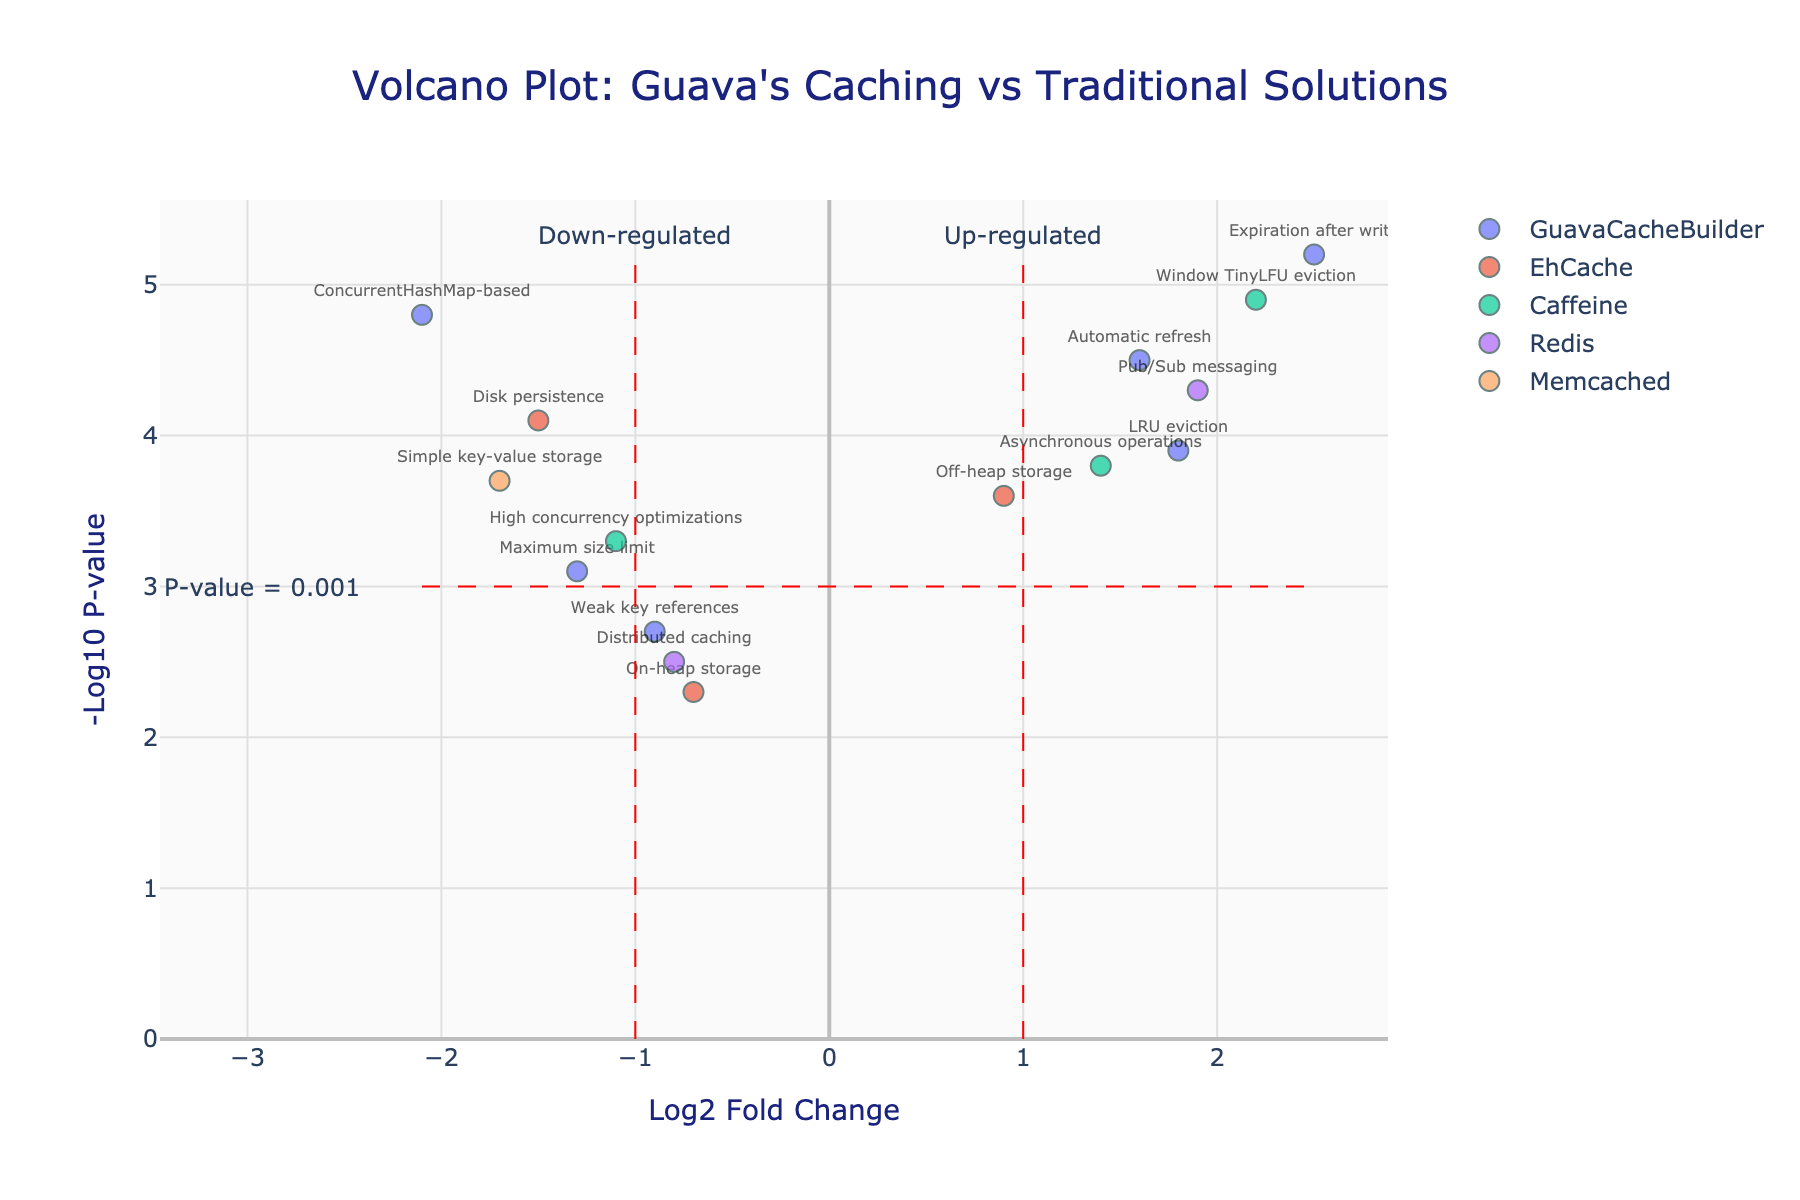What is the title of the figure? The title is displayed at the top of the figure and reads "Volcano Plot: Guava's Caching vs Traditional Solutions."
Answer: Volcano Plot: Guava's Caching vs Traditional Solutions How many data points are representing EhCache features? By examining the legend and the plot, there are three distinct markers labeled as EhCache on the figure.
Answer: 3 Which feature of Redis has the highest -Log10 P-value? By identifying points associated with Redis and checking their positions on the y-axis, the feature with the highest -Log10 P-value is "Pub/Sub messaging" at approximately 4.3.
Answer: Pub/Sub messaging What is the log2 fold change for the Guava feature with "Expiration after write"? Locate the data point labeled "Expiration after write" within the GuavaCacheBuilder marker set. The x-axis position corresponds to a log2 fold change of about 2.5.
Answer: 2.5 Which caching solution has a feature with the lowest log2 fold change? By comparing the x-axis positions, EhCache's "Disk persistence" shows the lowest log2 fold change at approximately -1.5.
Answer: EhCache What is the range of -Log10 P-values for features associated with GuavaCacheBuilder? Find all GuavaCacheBuilder points on the plot and note their y-axis positions. The values range from approximately 2.3 to 5.2.
Answer: 2.3 to 5.2 Which features have a negative log2 fold change but a -Log10 P-value greater than the threshold line (y=3)? Identify points left of x=0 and above y=3. The relevant features are "ConcurrentHashMap-based" and "Maximum size limit."
Answer: ConcurrentHashMap-based, Maximum size limit Compare the "Automatic refresh" feature of GuavaCacheBuilder with "High concurrency optimizations" of Caffeine in terms of both log2 fold change and -Log10 P-value. "Automatic refresh" (GuavaCacheBuilder) has a log2 fold change of 1.6 and -Log10 P-value of 4.5. "High concurrency optimizations" (Caffeine) has a log2 fold change of -1.1 and -Log10 P-value of 3.3. Thus, "Automatic refresh" has a higher log2 fold change and -Log10 P-value.
Answer: Automatic refresh is higher in both From which caching solution is the feature with the highest -Log10 P-value among all data points? By searching the entire plot, the feature with the highest -Log10 P-value is "Expiration after write" associated with GuavaCacheBuilder, with a value of 5.2.
Answer: GuavaCacheBuilder 